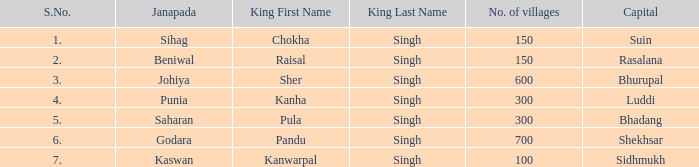What capital has an S.Number under 7, and a Name of janapada of Punia? Luddi. 